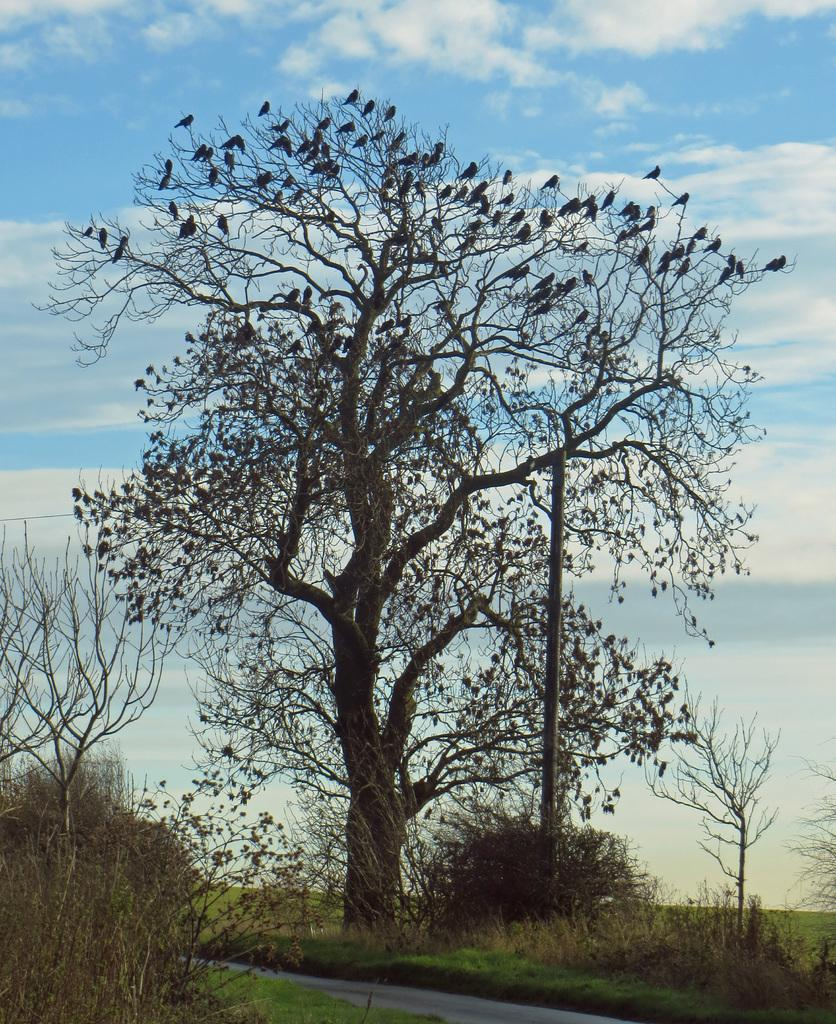What type of vegetation can be seen in the image? There are trees in the image. What structure is present in the image? There is a pole in the image. How would you describe the sky in the image? The sky is blue and cloudy in the image. What type of gold can be seen in the image? There is no gold present in the image. What season is depicted in the image? The provided facts do not mention any specific season, so it cannot be determined from the image. 